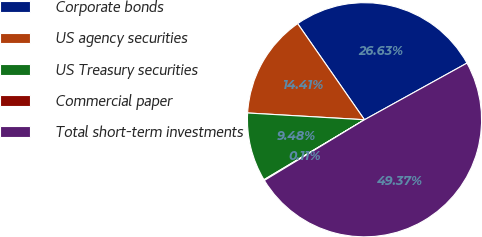Convert chart. <chart><loc_0><loc_0><loc_500><loc_500><pie_chart><fcel>Corporate bonds<fcel>US agency securities<fcel>US Treasury securities<fcel>Commercial paper<fcel>Total short-term investments<nl><fcel>26.63%<fcel>14.41%<fcel>9.48%<fcel>0.11%<fcel>49.37%<nl></chart> 